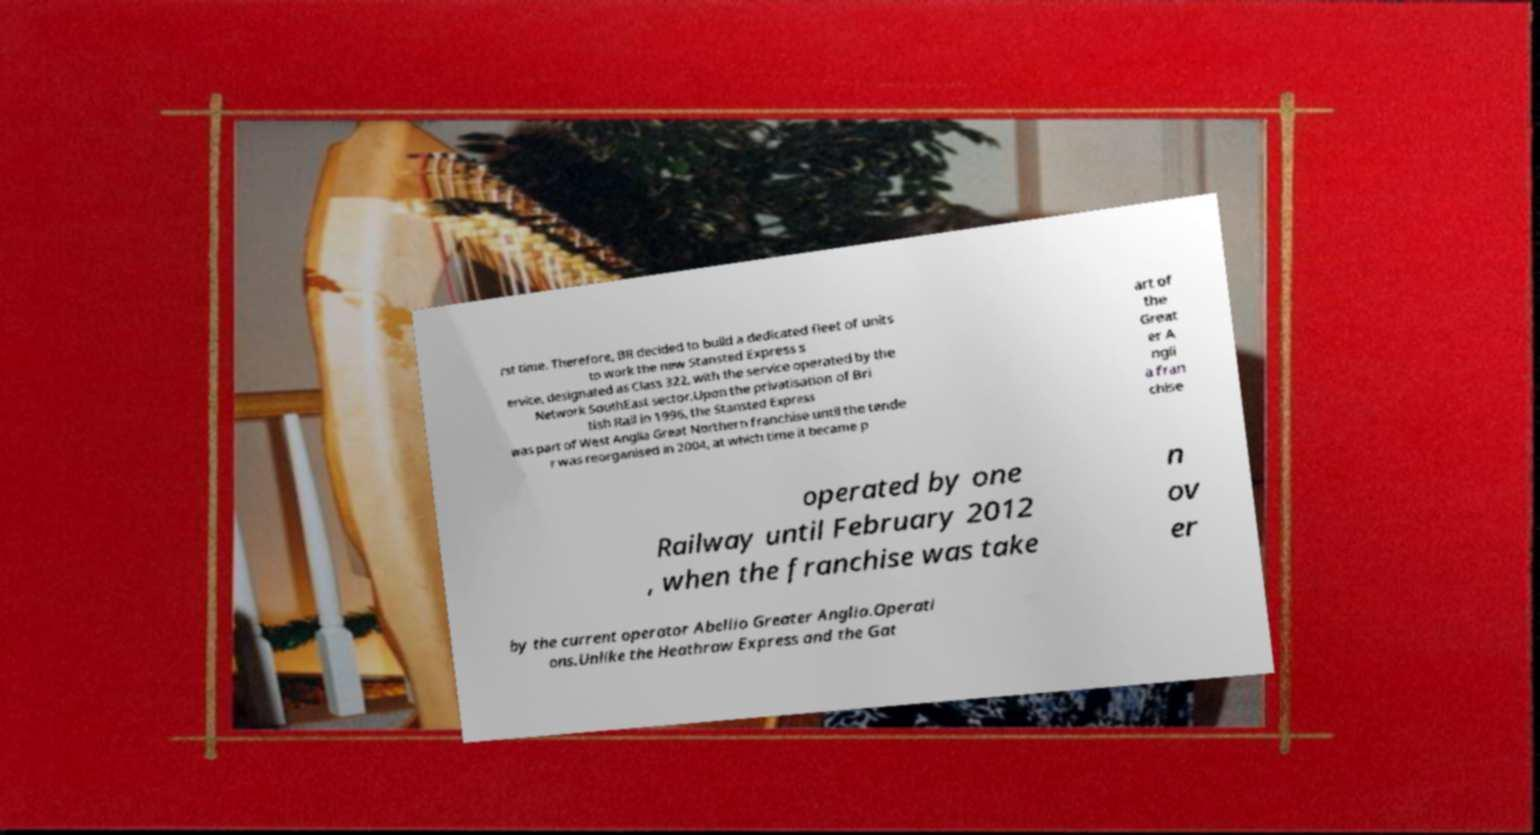There's text embedded in this image that I need extracted. Can you transcribe it verbatim? rst time. Therefore, BR decided to build a dedicated fleet of units to work the new Stansted Express s ervice, designated as Class 322, with the service operated by the Network SouthEast sector.Upon the privatisation of Bri tish Rail in 1996, the Stansted Express was part of West Anglia Great Northern franchise until the tende r was reorganised in 2004, at which time it became p art of the Great er A ngli a fran chise operated by one Railway until February 2012 , when the franchise was take n ov er by the current operator Abellio Greater Anglia.Operati ons.Unlike the Heathrow Express and the Gat 